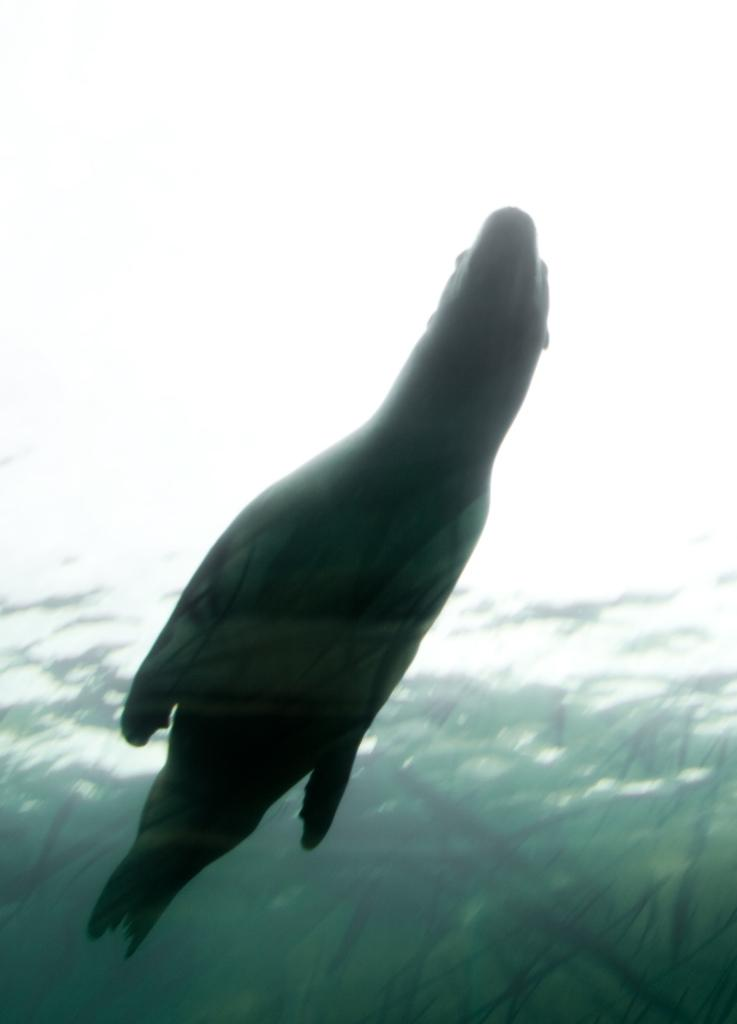What animal is featured in the image? There is a dolphin in the image. What is the dolphin doing in the image? The dolphin is swimming in the water. What type of root can be seen growing near the dolphin in the image? There is no root present in the image, as it features a dolphin swimming in the water. 